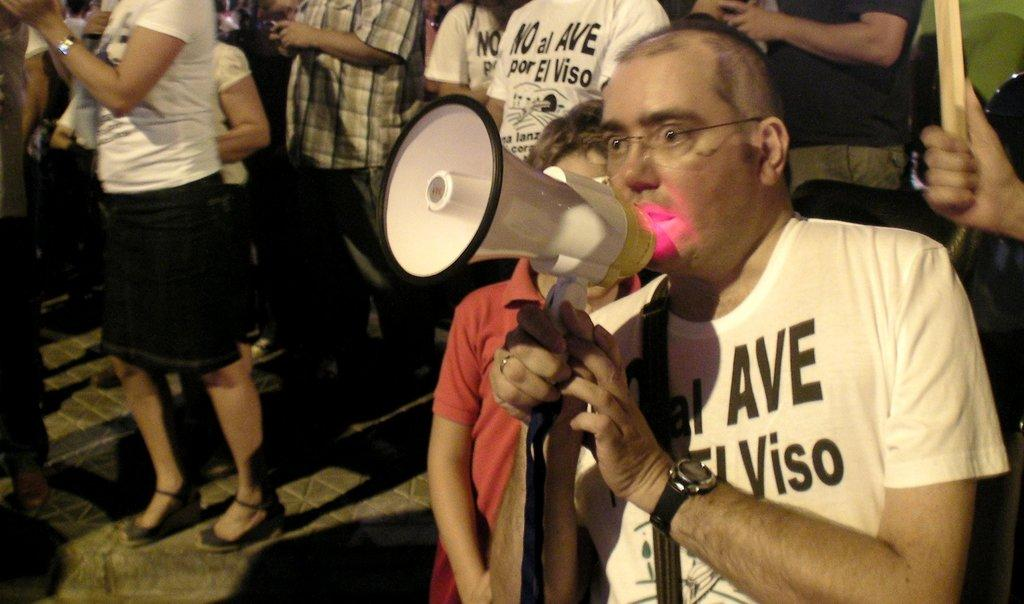Who is the main subject in the image? There is a man in the image. What is the man holding in the image? The man is holding a loudspeaker. How is the loudspeaker being held by the man? The loudspeaker is being held with the man's hands. Can you describe the other people in the image? There is a group of people in the image, and they are standing on the floor. What type of milk is being served to the dad in the image? There is no dad or milk present in the image. What season is depicted in the image? The provided facts do not mention any season or weather-related details, so it cannot be determined from the image. 